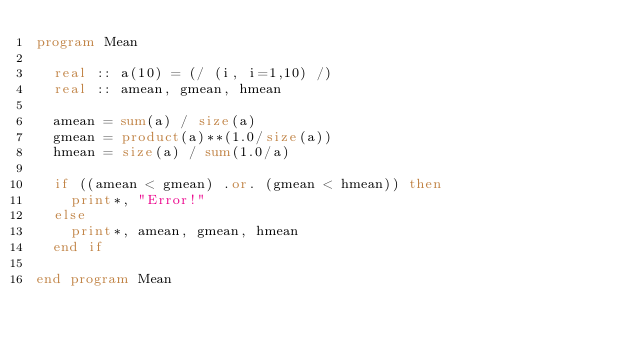Convert code to text. <code><loc_0><loc_0><loc_500><loc_500><_FORTRAN_>program Mean

  real :: a(10) = (/ (i, i=1,10) /)
  real :: amean, gmean, hmean

  amean = sum(a) / size(a)
  gmean = product(a)**(1.0/size(a))
  hmean = size(a) / sum(1.0/a)

  if ((amean < gmean) .or. (gmean < hmean)) then
    print*, "Error!"
  else
    print*, amean, gmean, hmean
  end if

end program Mean
</code> 